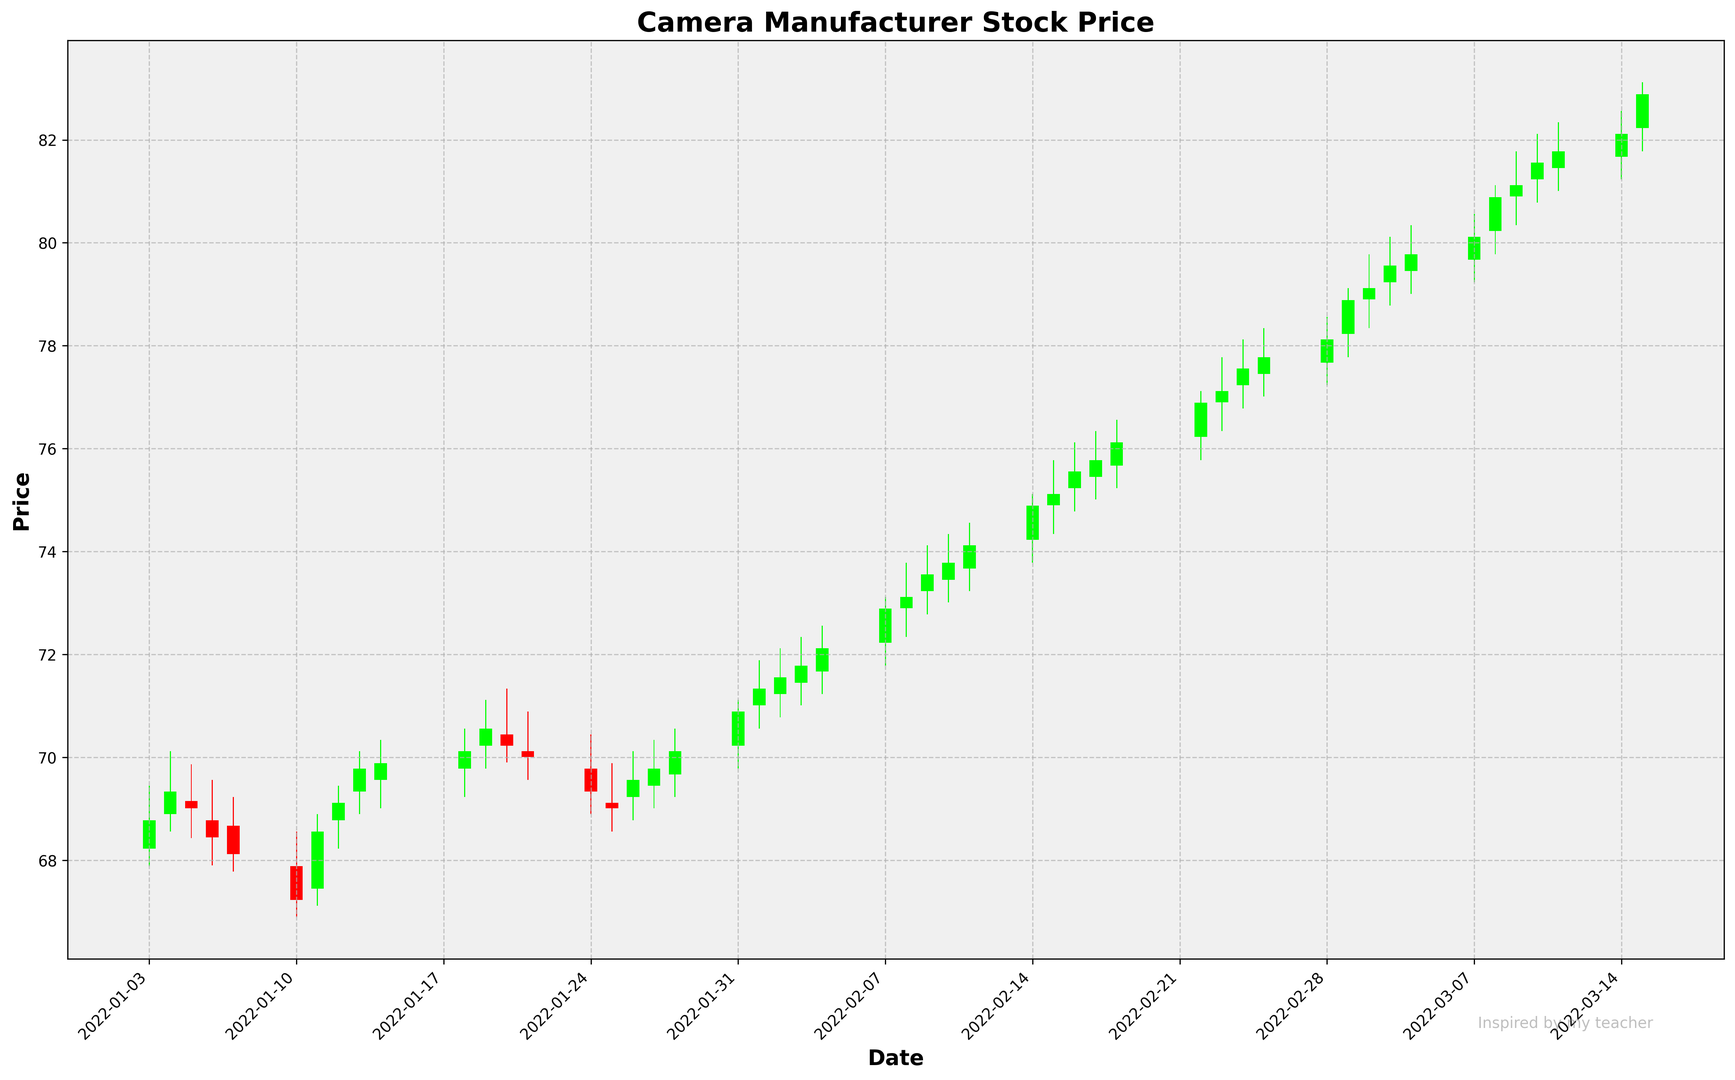What is the general trend in the stock price over the period shown in the figure? The stock price generally trends upward over the period shown. The figure shows green bars dominating towards the latter half, indicating days where the closing prices are higher than the opening prices.
Answer: Upward Which month shows the highest closing price and what is that price? From observing the candlesticks, the highest closing price appears in March 2022. By examining the height of the candlesticks and the closing prices, the highest closing price is around 82.89 on 2022-03-09.
Answer: March 2022, 82.89 On which date was the largest difference between the high and low prices? The largest difference between high and low prices can be identified by looking at the length of the wicks. The longest wick appears on 2022-03-08.
Answer: 2022-03-08 How does the stock price on the last day of the chart compare to the first day? The last day on the chart is 2022-03-15 and the first day is 2022-01-03. The closing price on 2022-01-03 was 68.78, and on 2022-03-15, it was 82.89. The price has significantly increased.
Answer: Increased What is the average closing price for February 2022? Sum the closing prices for all dates in February 2022, then divide by the number of dates. Calculations: (72.12+72.89+73.12+73.56+73.78+74.12+74.89+75.12+75.56+75.78+76.12+76.89+77.12+77.56+77.78+78.12) / 16 = 75.09 (rounded to two decimal places).
Answer: 75.09 Which date had the largest increase in stock price from open to close? Identify the bar with the largest green body since green bars indicate the closing price is higher than the opening price. The date with the largest increase from open to close is 2022-02-07.
Answer: 2022-02-07 Was there a period where the stock price consistently increased over several days? Looking for consecutive green bars may help to identify such a period. Notably, there is an increasing trend from 2022-02-07 to 2022-02-11 with green bars representing continuous daily increases.
Answer: Yes, from 2022-02-07 to 2022-02-11 Are there more red bars or green bars in February 2022? Count the number of red and green bars within the month of February 2022. There are more green bars than red bars in February 2022.
Answer: More green bars What is the longest period without any red bars in the graph? Identify the longest streak of green bars without any red bars in between. The longest period is from 2022-02-07 to 2022-02-14, where the bars are all green.
Answer: 2022-02-07 to 2022-02-14 